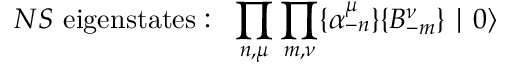<formula> <loc_0><loc_0><loc_500><loc_500>N S e i g e n s t a t e s \colon \, \prod _ { n , \mu } \prod _ { m , \nu } \{ \alpha _ { - n } ^ { \mu } \} \{ B _ { - m } ^ { \nu } \} | 0 \rangle</formula> 